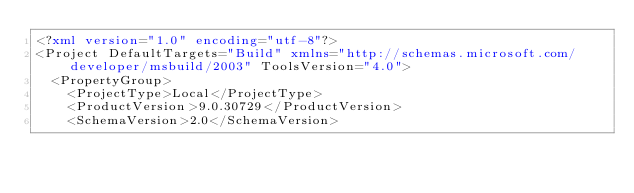<code> <loc_0><loc_0><loc_500><loc_500><_XML_><?xml version="1.0" encoding="utf-8"?>
<Project DefaultTargets="Build" xmlns="http://schemas.microsoft.com/developer/msbuild/2003" ToolsVersion="4.0">
  <PropertyGroup>
    <ProjectType>Local</ProjectType>
    <ProductVersion>9.0.30729</ProductVersion>
    <SchemaVersion>2.0</SchemaVersion></code> 